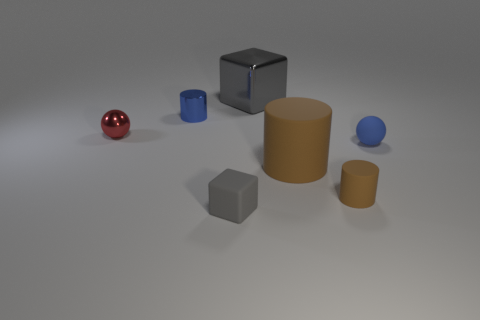What is the color of the big thing that is in front of the large object that is behind the blue rubber sphere?
Ensure brevity in your answer.  Brown. What number of tiny objects are right of the blue cylinder and behind the tiny gray rubber block?
Your answer should be compact. 2. Is the number of tiny gray metallic balls greater than the number of big gray shiny things?
Provide a succinct answer. No. What material is the blue cylinder?
Your answer should be very brief. Metal. How many blue balls are on the right side of the small blue object to the left of the gray metal object?
Your response must be concise. 1. There is a large metal cube; is its color the same as the large thing that is in front of the red object?
Ensure brevity in your answer.  No. The metal ball that is the same size as the gray rubber cube is what color?
Offer a terse response. Red. Are there any other objects of the same shape as the large gray thing?
Your response must be concise. Yes. Is the number of blue metallic objects less than the number of brown matte objects?
Your answer should be compact. Yes. The cylinder behind the tiny shiny ball is what color?
Your answer should be very brief. Blue. 